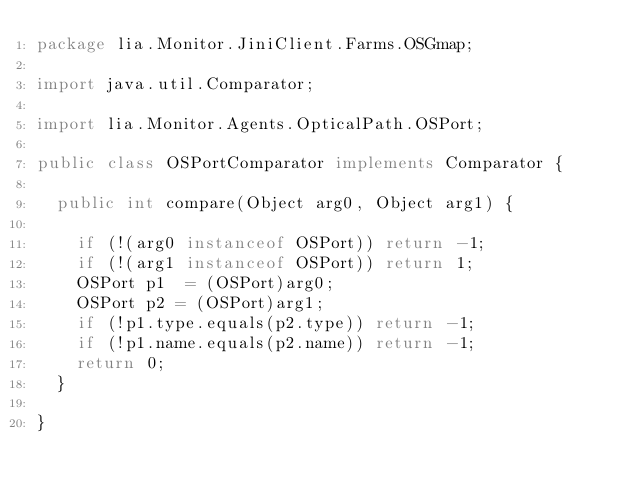<code> <loc_0><loc_0><loc_500><loc_500><_Java_>package lia.Monitor.JiniClient.Farms.OSGmap;

import java.util.Comparator;

import lia.Monitor.Agents.OpticalPath.OSPort;

public class OSPortComparator implements Comparator {

	public int compare(Object arg0, Object arg1) {
		
		if (!(arg0 instanceof OSPort)) return -1;
		if (!(arg1 instanceof OSPort)) return 1;
		OSPort p1  = (OSPort)arg0;
		OSPort p2 = (OSPort)arg1;
		if (!p1.type.equals(p2.type)) return -1;
		if (!p1.name.equals(p2.name)) return -1;
		return 0;
	}

}
</code> 